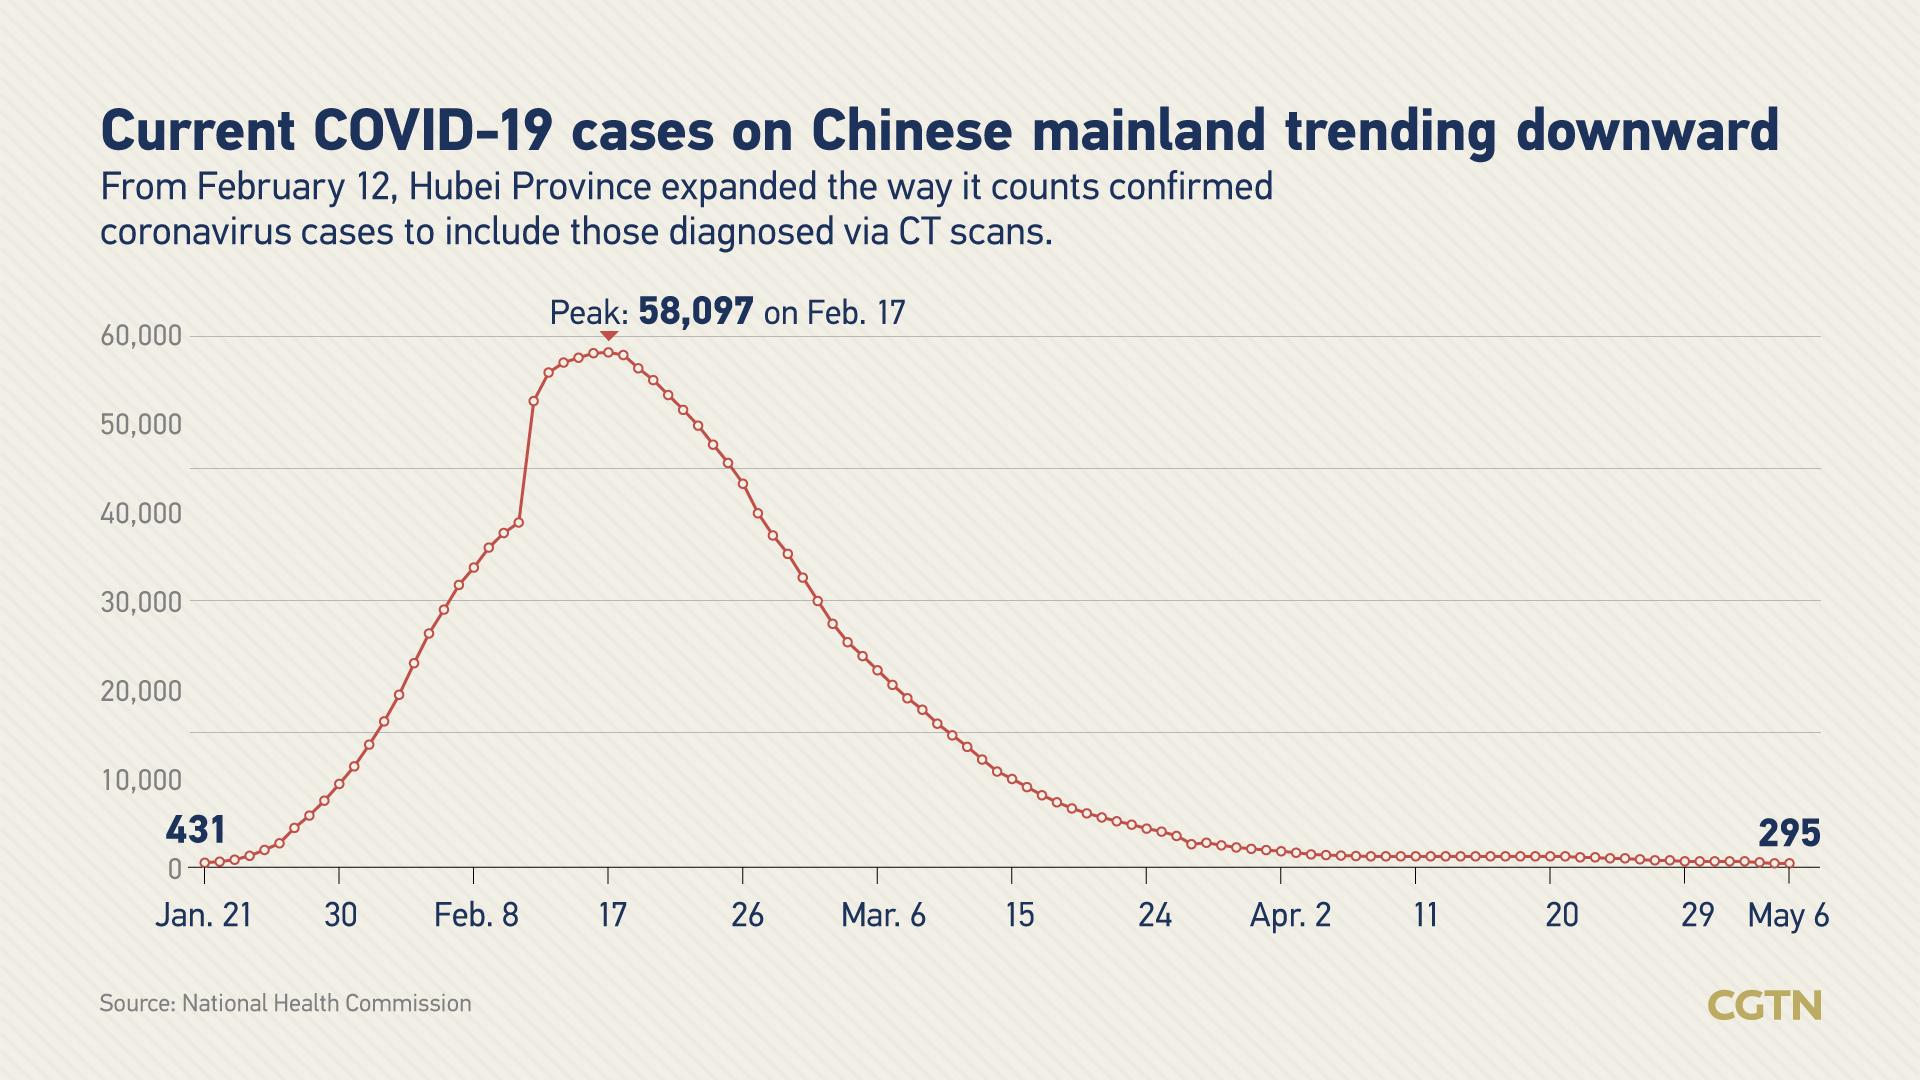Specify some key components in this picture. During the month of February, there was a vertical surge in the number of COVID-19 cases, with the highest number of cases reported from February 17 to February 26. However, it is important to note that the number of cases also increased significantly during the period of February 8 to February 17. The plot includes 5 months. On May 6th, the number of coronavirus cases was significantly lower compared to the number of cases reported on January 21st. On February 17th, there were significantly more reported cases of the coronavirus than on January 21st. In the first week of February, there were more cases of COVID-19 than in either the first week of January or the first week of April. 